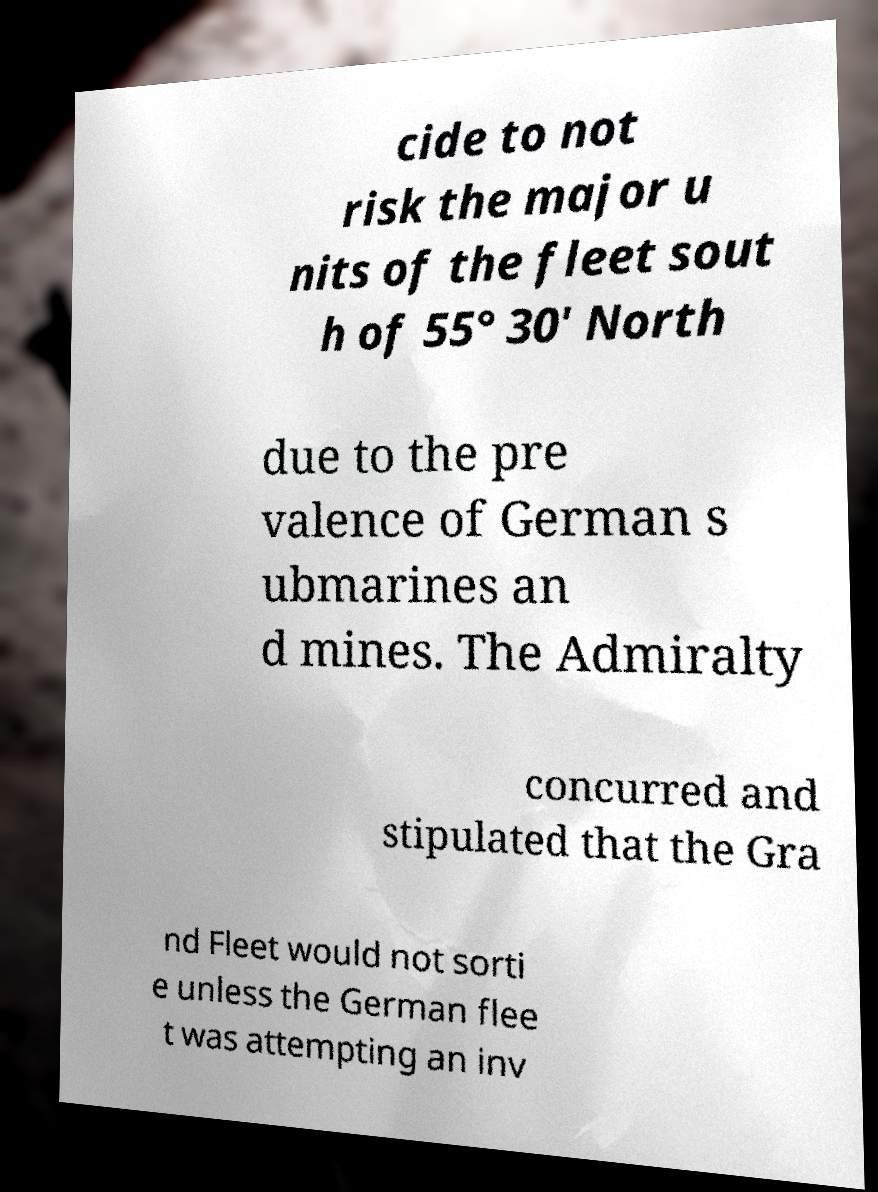Could you extract and type out the text from this image? cide to not risk the major u nits of the fleet sout h of 55° 30' North due to the pre valence of German s ubmarines an d mines. The Admiralty concurred and stipulated that the Gra nd Fleet would not sorti e unless the German flee t was attempting an inv 